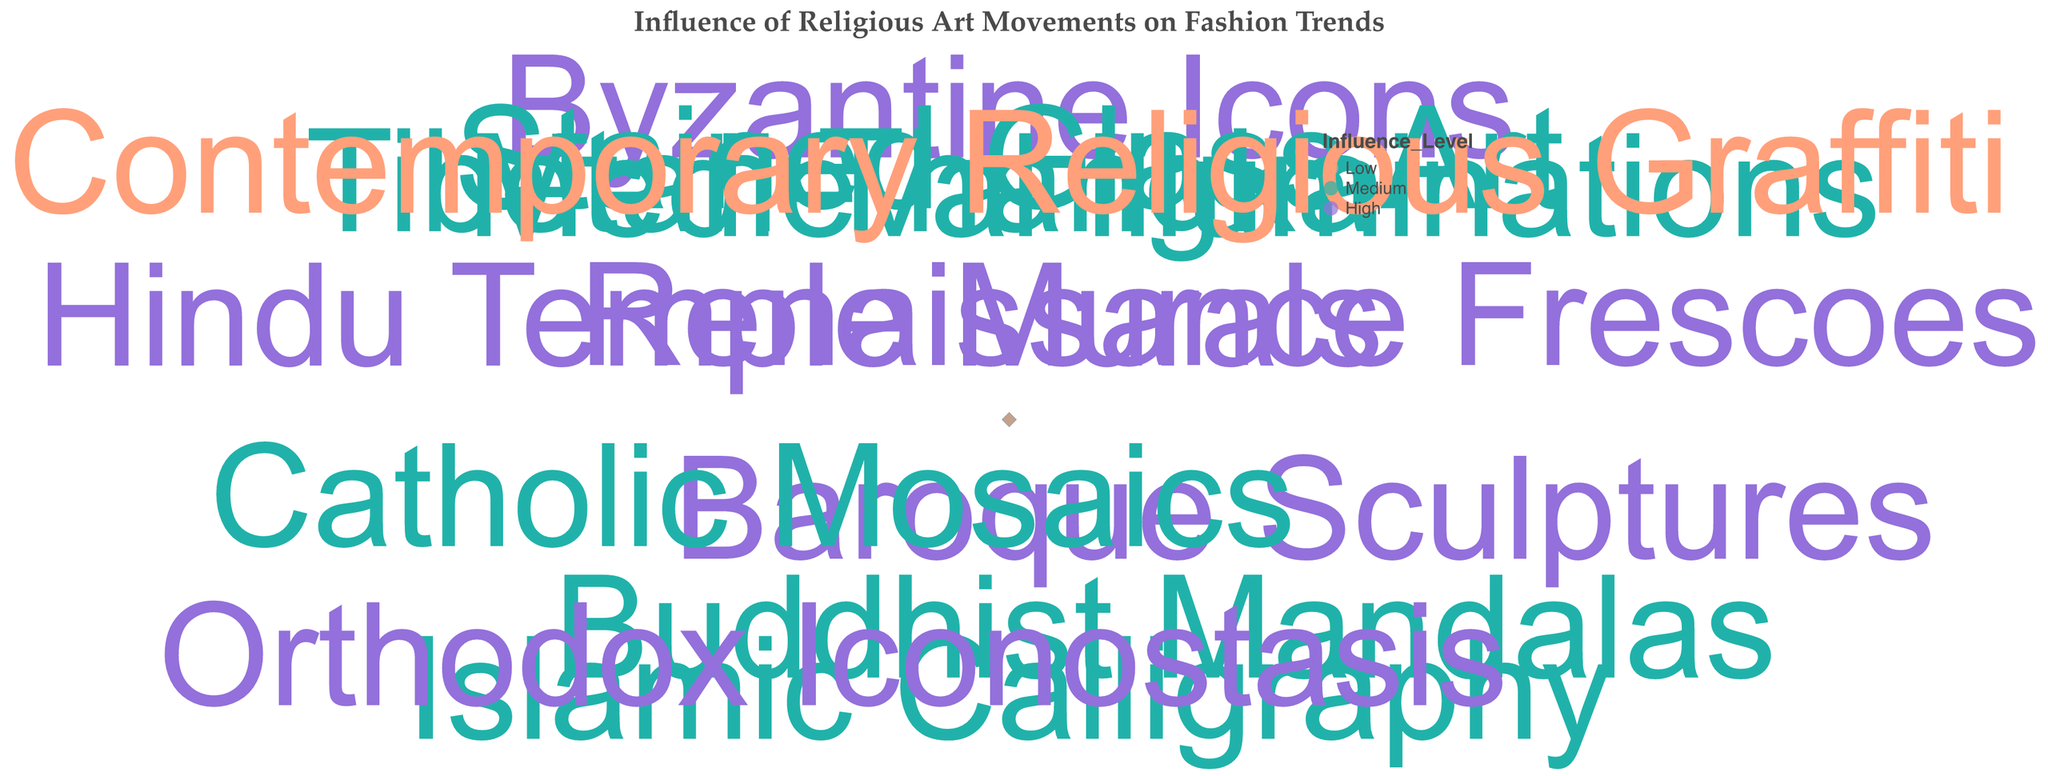What does the title of the figure indicate? The title, "Influence of Religious Art Movements on Fashion Trends," indicates that the figure illustrates how various religious art movements have influenced fashion trends over different decades.
Answer: Influence of Religious Art Movements on Fashion Trends What color represents a "High" influence level? Observing the color legend in the figure, the color associated with "High" influence level is purple.
Answer: Purple How many data points are colored as "Low" influence level? Looking at the figure, there is one data point colored in the shade representing "Low" influence level, which is a peach color.
Answer: 1 Which influence source has the highest impact factor? The highest impact factor, 8.1, belongs to "Renaissance Frescoes" in the 1940s, as indicated by the radial position of the point.
Answer: Renaissance Frescoes What is the impact factor for "Contemporary Religious Graffiti" in 2020? From the figure, the point corresponding to "Contemporary Religious Graffiti" in the 2020 decade shows an impact factor of 4.8.
Answer: 4.8 Which decade has the highest number of "High" influence level sources? Analyzing the distribution of purple-colored points across decades, each "High" influence level source is fairly even, but the highest numbers are present in the 1920s and 2000s, with two each.
Answer: 1920s and 2000s Compare the impact factor of "Buddhist Mandalas" in the 1960s with "Tibetan Thangka" in the 2010s. Which one is higher? Looking at the radial positions, "Buddhist Mandalas" has an impact factor of 5.5, and "Tibetan Thangka" has an impact factor of 6.5. Hence, "Tibetan Thangka" in the 2010s has a higher impact factor.
Answer: Tibetan Thangka What is the median impact factor for the "Medium" influence level sources? The impact factors for "Medium" influence levels are 5.0, 6.2, 5.5, 6.0, 5.7, 6.5. Ordering these: 5.0, 5.5, 5.7, 6.0, 6.2, 6.5. The median is the average of 5.7 and 6.0, calculated as (5.7 + 6.0) / 2 = 5.85
Answer: 5.85 What is the average impact factor for "High" influence level sources? Adding the impact factors for "High" influence levels: 7.5 (Byzantine Icons) + 8.1 (Renaissance Frescoes) + 7.8 (Baroque Sculptures) + 7.2 (Orthodox Iconostasis) + 8.0 (Hindu Temple Murals) = 38.6. There are 5 sources, so the average is 38.6 / 5 = 7.72
Answer: 7.72 